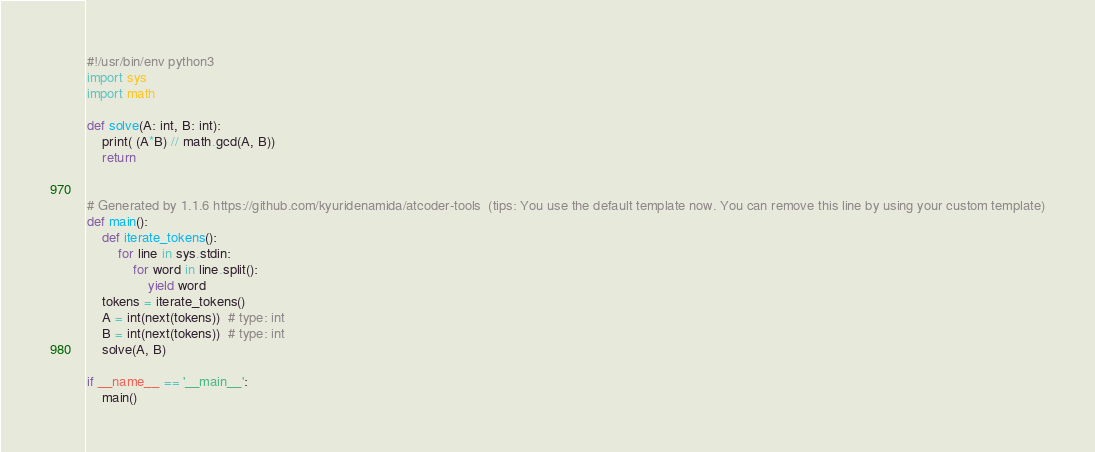<code> <loc_0><loc_0><loc_500><loc_500><_Python_>#!/usr/bin/env python3
import sys
import math

def solve(A: int, B: int):
    print( (A*B) // math.gcd(A, B))
    return


# Generated by 1.1.6 https://github.com/kyuridenamida/atcoder-tools  (tips: You use the default template now. You can remove this line by using your custom template)
def main():
    def iterate_tokens():
        for line in sys.stdin:
            for word in line.split():
                yield word
    tokens = iterate_tokens()
    A = int(next(tokens))  # type: int
    B = int(next(tokens))  # type: int
    solve(A, B)

if __name__ == '__main__':
    main()
</code> 